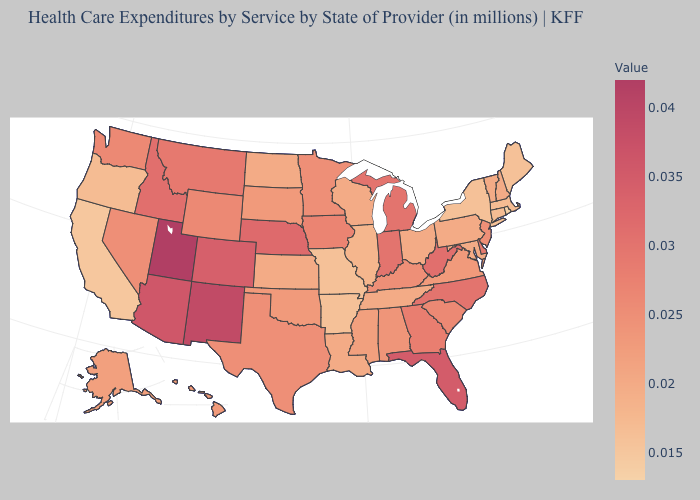Does the map have missing data?
Answer briefly. No. Does Arkansas have the lowest value in the South?
Concise answer only. Yes. Does Connecticut have the highest value in the USA?
Be succinct. No. Does the map have missing data?
Quick response, please. No. 